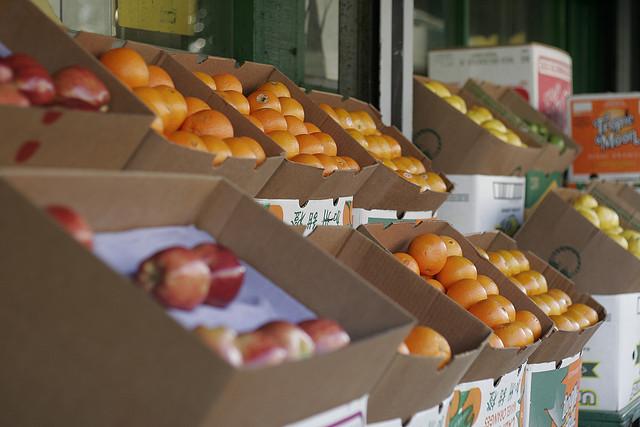How many boxes are there?
Answer briefly. 12. What fruits are here?
Concise answer only. Apples and oranges. Are the fruits peeled?
Quick response, please. No. 